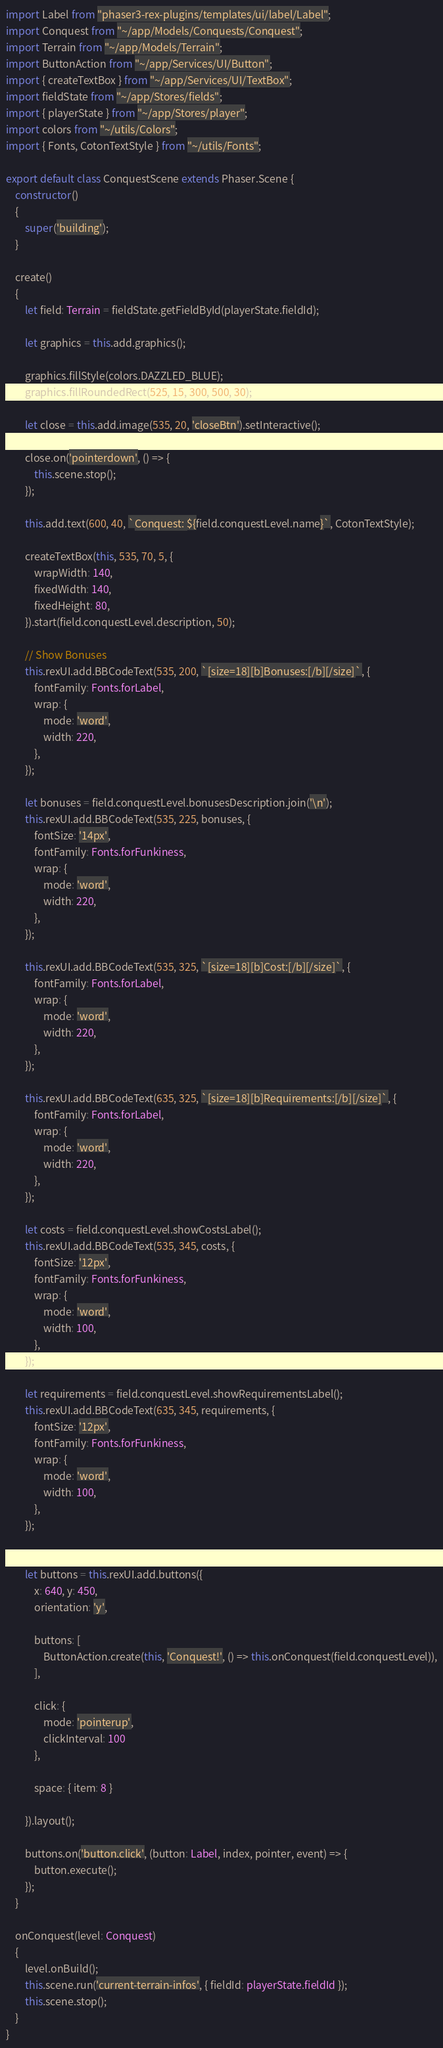<code> <loc_0><loc_0><loc_500><loc_500><_TypeScript_>import Label from "phaser3-rex-plugins/templates/ui/label/Label";
import Conquest from "~/app/Models/Conquests/Conquest";
import Terrain from "~/app/Models/Terrain";
import ButtonAction from "~/app/Services/UI/Button";
import { createTextBox } from "~/app/Services/UI/TextBox";
import fieldState from "~/app/Stores/fields";
import { playerState } from "~/app/Stores/player";
import colors from "~/utils/Colors";
import { Fonts, CotonTextStyle } from "~/utils/Fonts";

export default class ConquestScene extends Phaser.Scene {
    constructor()
    {
        super('building');
    }

    create()
    {
        let field: Terrain = fieldState.getFieldById(playerState.fieldId);

        let graphics = this.add.graphics();

        graphics.fillStyle(colors.DAZZLED_BLUE);
        graphics.fillRoundedRect(525, 15, 300, 500, 30);

        let close = this.add.image(535, 20, 'closeBtn').setInteractive();

        close.on('pointerdown', () => {
            this.scene.stop();
        });

        this.add.text(600, 40, `Conquest: ${field.conquestLevel.name}`, CotonTextStyle);

        createTextBox(this, 535, 70, 5, {
            wrapWidth: 140,
            fixedWidth: 140,
            fixedHeight: 80,
        }).start(field.conquestLevel.description, 50);

        // Show Bonuses
        this.rexUI.add.BBCodeText(535, 200, `[size=18][b]Bonuses:[/b][/size]`, {
            fontFamily: Fonts.forLabel,
            wrap: {
                mode: 'word',
                width: 220,
            },
        });

        let bonuses = field.conquestLevel.bonusesDescription.join('\n');
        this.rexUI.add.BBCodeText(535, 225, bonuses, {
            fontSize: '14px',
            fontFamily: Fonts.forFunkiness,
            wrap: {
                mode: 'word',
                width: 220,
            },
        });

        this.rexUI.add.BBCodeText(535, 325, `[size=18][b]Cost:[/b][/size]`, {
            fontFamily: Fonts.forLabel,
            wrap: {
                mode: 'word',
                width: 220,
            },
        });

        this.rexUI.add.BBCodeText(635, 325, `[size=18][b]Requirements:[/b][/size]`, {
            fontFamily: Fonts.forLabel,
            wrap: {
                mode: 'word',
                width: 220,
            },
        });

        let costs = field.conquestLevel.showCostsLabel();
        this.rexUI.add.BBCodeText(535, 345, costs, {
            fontSize: '12px',
            fontFamily: Fonts.forFunkiness,
            wrap: {
                mode: 'word',
                width: 100,
            },
        });

        let requirements = field.conquestLevel.showRequirementsLabel();
        this.rexUI.add.BBCodeText(635, 345, requirements, {
            fontSize: '12px',
            fontFamily: Fonts.forFunkiness,
            wrap: {
                mode: 'word',
                width: 100,
            },
        });


        let buttons = this.rexUI.add.buttons({
            x: 640, y: 450,
            orientation: 'y',

            buttons: [
                ButtonAction.create(this, 'Conquest!', () => this.onConquest(field.conquestLevel)),
            ],

            click: {
                mode: 'pointerup',
                clickInterval: 100
            },

            space: { item: 8 }

        }).layout();

        buttons.on('button.click', (button: Label, index, pointer, event) => {
            button.execute();
        });
    }

    onConquest(level: Conquest)
    {
        level.onBuild();
        this.scene.run('current-terrain-infos', { fieldId: playerState.fieldId });
        this.scene.stop();
    }
}</code> 